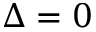<formula> <loc_0><loc_0><loc_500><loc_500>\Delta = 0</formula> 